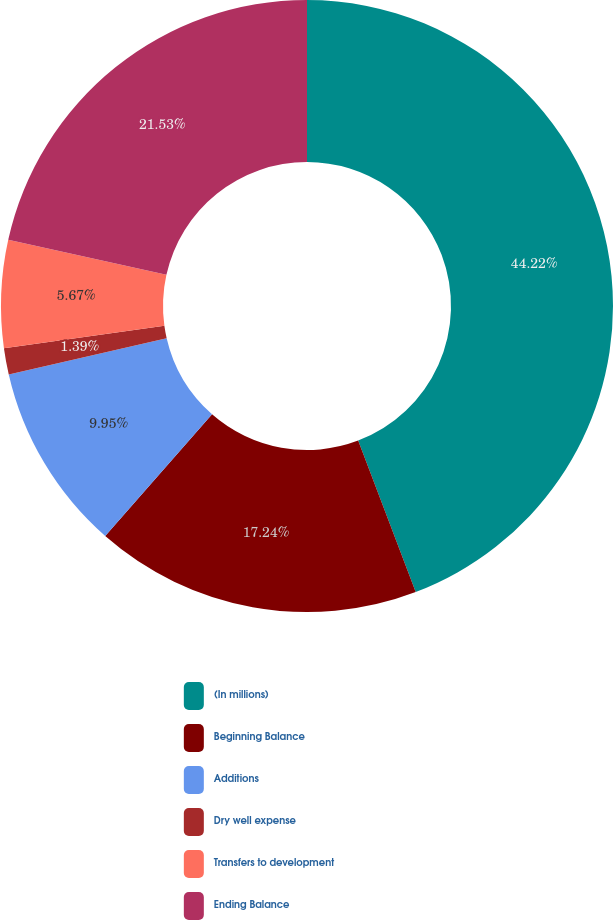<chart> <loc_0><loc_0><loc_500><loc_500><pie_chart><fcel>(In millions)<fcel>Beginning Balance<fcel>Additions<fcel>Dry well expense<fcel>Transfers to development<fcel>Ending Balance<nl><fcel>44.22%<fcel>17.24%<fcel>9.95%<fcel>1.39%<fcel>5.67%<fcel>21.53%<nl></chart> 